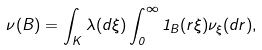<formula> <loc_0><loc_0><loc_500><loc_500>\nu ( B ) = \int _ { K } \lambda ( d \xi ) \int _ { 0 } ^ { \infty } 1 _ { B } ( r \xi ) \nu _ { \xi } ( d r ) ,</formula> 